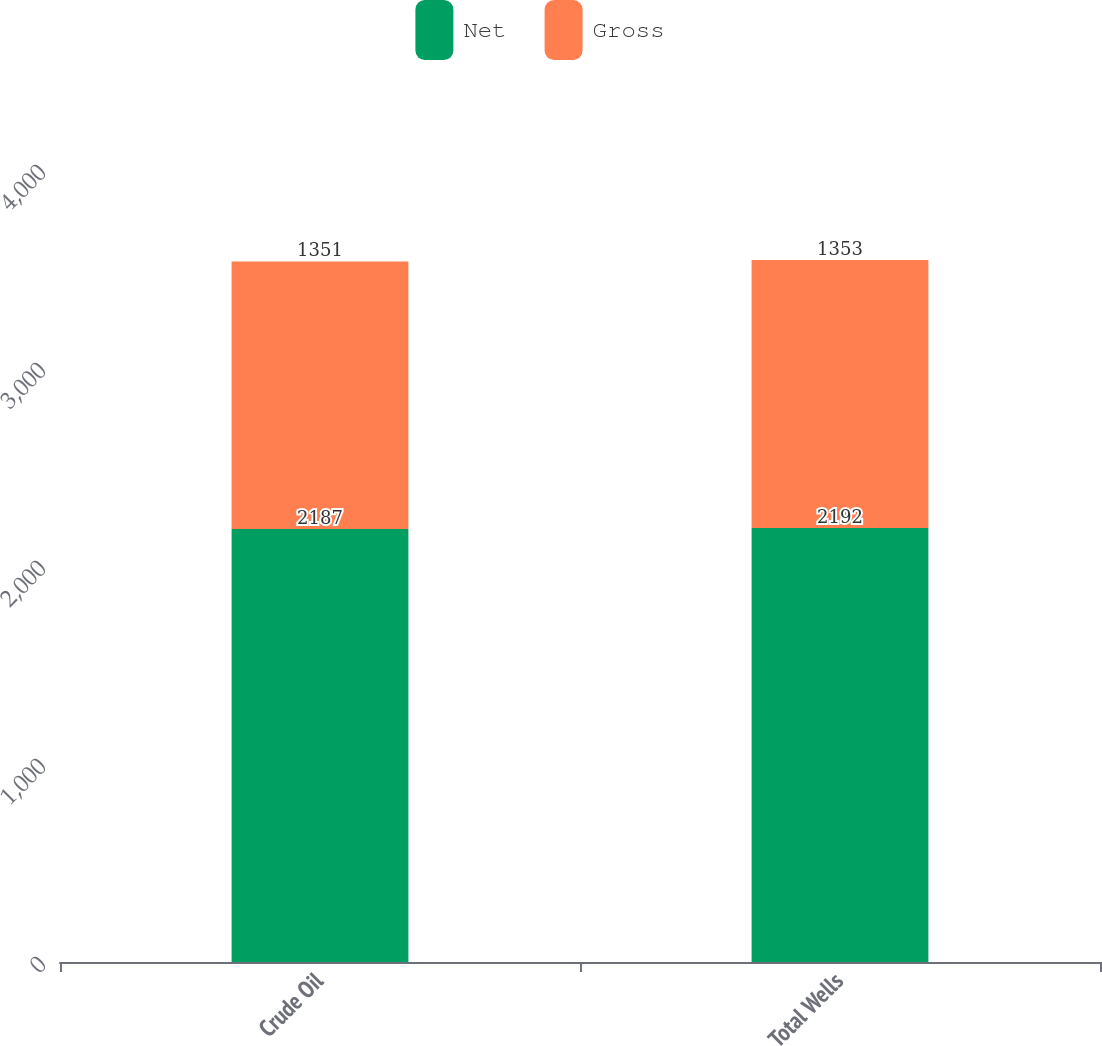Convert chart. <chart><loc_0><loc_0><loc_500><loc_500><stacked_bar_chart><ecel><fcel>Crude Oil<fcel>Total Wells<nl><fcel>Net<fcel>2187<fcel>2192<nl><fcel>Gross<fcel>1351<fcel>1353<nl></chart> 